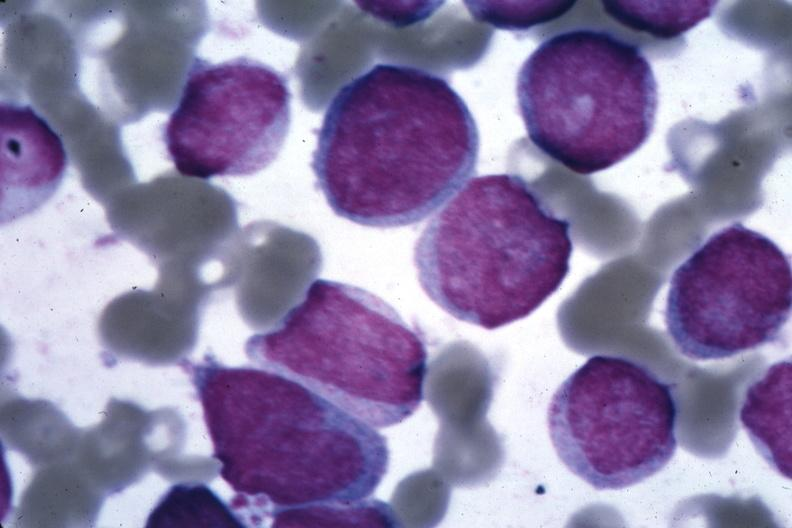what is present?
Answer the question using a single word or phrase. Bone marrow 